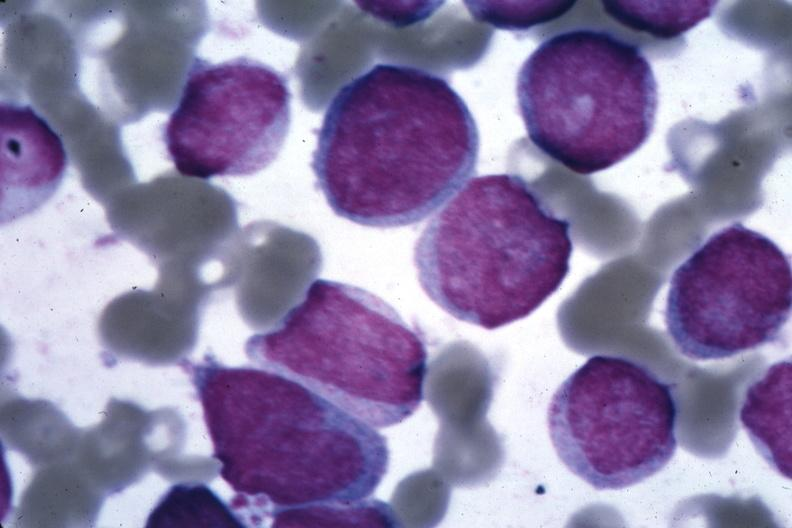what is present?
Answer the question using a single word or phrase. Bone marrow 